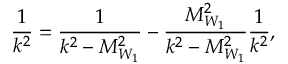<formula> <loc_0><loc_0><loc_500><loc_500>\frac { 1 } { k ^ { 2 } } = \frac { 1 } { k ^ { 2 } - M _ { W _ { 1 } } ^ { 2 } } - \frac { M _ { W _ { 1 } } ^ { 2 } } { k ^ { 2 } - M _ { W _ { 1 } } ^ { 2 } } \frac { 1 } { k ^ { 2 } } ,</formula> 